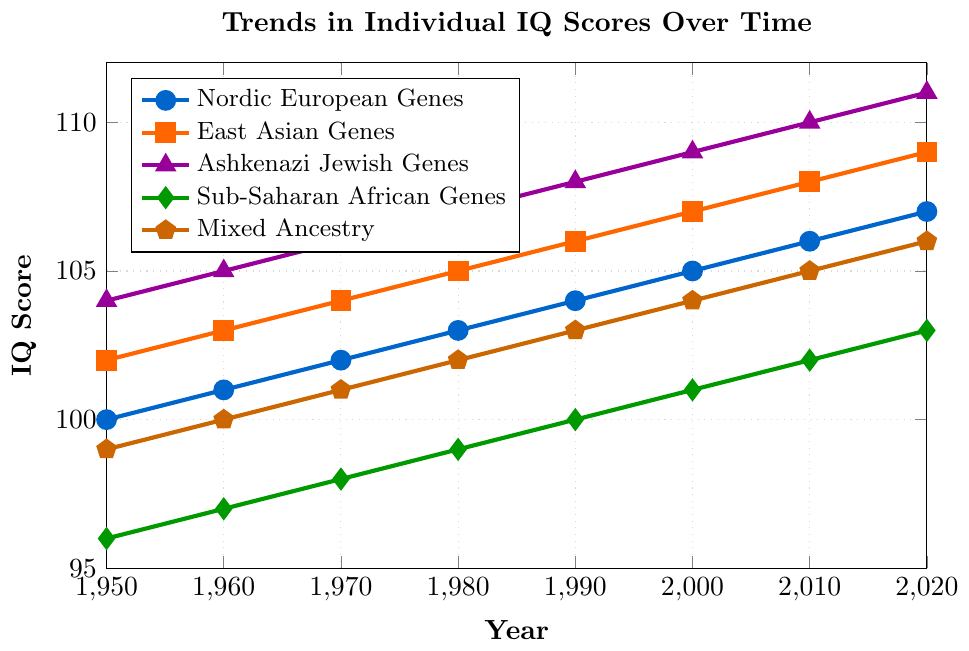What trend is observed for the Nordic European Genes IQ scores from 1950 to 2020? The figure shows IQ scores for the Nordic European Genes over time. Observing the plotted line, there is a consistent upward trend, increasing from 100 in 1950 to 107 in 2020.
Answer: Consistent increase Which genetic group has the highest IQ score in the year 2020? By examining the different lines on the graph at the 2020 mark, the Ashkenazi Jewish Genes group reaches the highest IQ score of 111.
Answer: Ashkenazi Jewish Genes How does the increase in IQ score for Sub-Saharan African Genes compare to that of Mixed Ancestry from 1950 to 2020? By calculating the difference for each group, Sub-Saharan African Genes increased from 96 to 103 (7 points), and Mixed Ancestry increased from 99 to 106 (7 points). Both groups have the same increase in IQ scores over this period.
Answer: Same increase of 7 points What is the IQ score difference between East Asian Genes and Ashkenazi Jewish Genes in 2010? In 2010, the IQ scores for East Asian Genes and Ashkenazi Jewish Genes are 108 and 110, respectively. Calculating the difference: 110 - 108 = 2.
Answer: 2 points Are there any genetic groups whose IQ scores increased by at least 1 point every decade from 1950 to 2020? By examining the slopes of the lines for each group, all groups except Sub-Saharan African Genes show an increase of at least 1 point every decade from 1950 to 2020. Sub-Saharan African Genes increased by 1 point every two decades initially.
Answer: All except Sub-Saharan African Genes What is the average IQ score for East Asian Genes from 1950 to 2020? To find the average, sum the IQ scores for East Asian Genes across all years and divide by the number of data points: (102 + 103 + 104 + 105 + 106 + 107 + 108 + 109) / 8 = 844 / 8 = 105.5.
Answer: 105.5 Compare the slopes of the lines representing Nordic European Genes and Ashkenazi Jewish Genes. Which one shows a steeper increase? The slope is calculated by the change in the IQ score divided by the number of years. For Nordic European, (107 - 100) / 70 = 0.1. For Ashkenazi Jewish Genes, (111 - 104) / 70 = 0.1. Both slopes are equal, indicating the same rate of increase.
Answer: Equal rate of increase What pattern can be seen in the IQ scores for Mixed Ancestry over time? Observing the plotted line for Mixed Ancestry, there is a steady and consistent increase from 99 in 1950 to 106 in 2020, showing no sharp changes or irregularities.
Answer: Steady increase Which genetic group shows the smallest change in IQ score from 1950 to 2020? By calculating the total change for each group, Sub-Saharan African Genes show the smallest change, increasing by 7 points from 96 to 103.
Answer: Sub-Saharan African Genes 